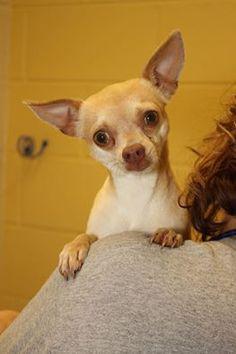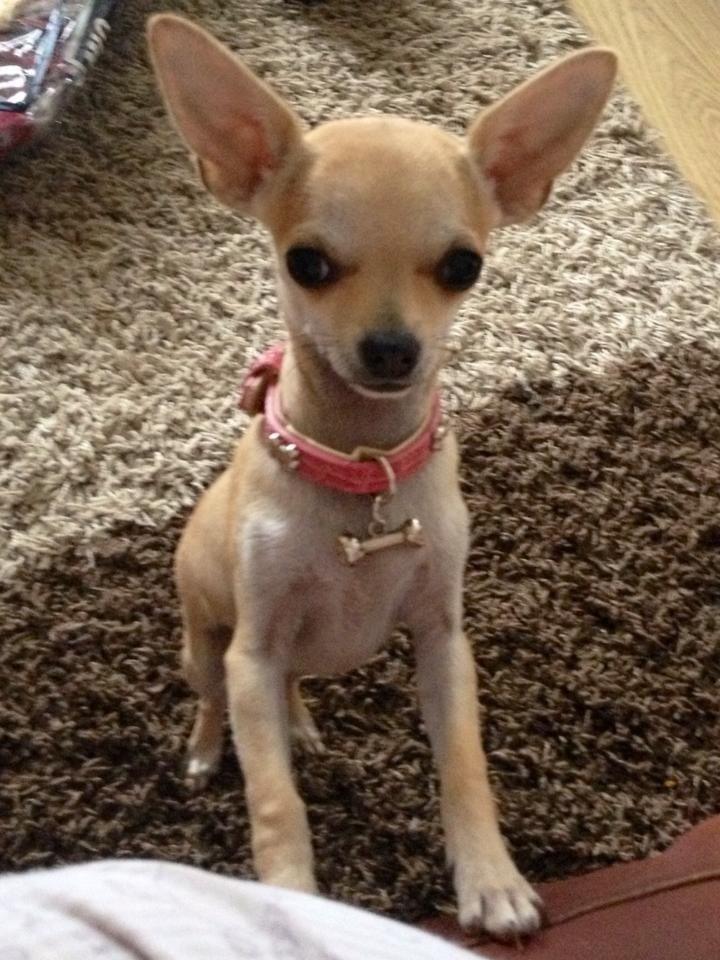The first image is the image on the left, the second image is the image on the right. Examine the images to the left and right. Is the description "The dog in the image on the left has a white collar." accurate? Answer yes or no. No. The first image is the image on the left, the second image is the image on the right. Analyze the images presented: Is the assertion "A chihuahua is sitting on a rug." valid? Answer yes or no. Yes. 